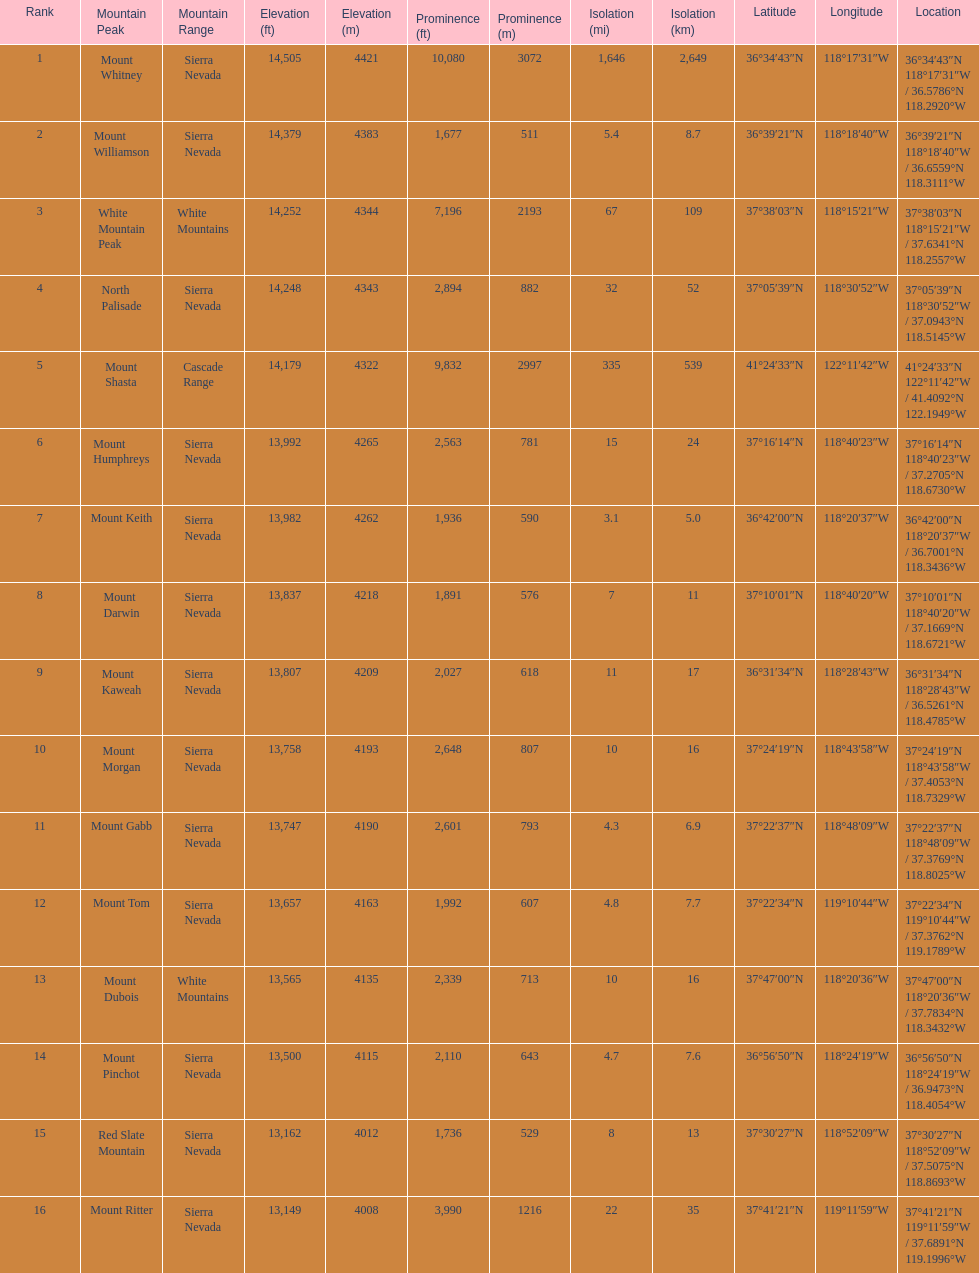Which mountain peak is no higher than 13,149 ft? Mount Ritter. 